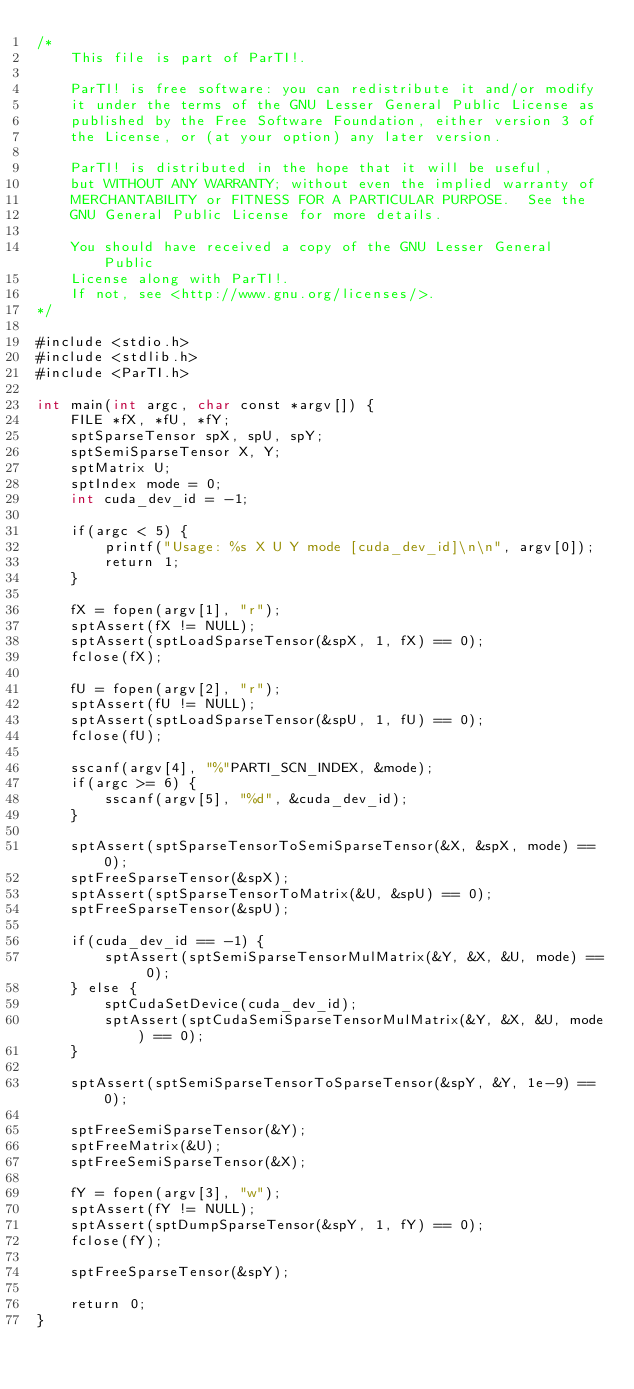<code> <loc_0><loc_0><loc_500><loc_500><_Cuda_>/*
    This file is part of ParTI!.

    ParTI! is free software: you can redistribute it and/or modify
    it under the terms of the GNU Lesser General Public License as
    published by the Free Software Foundation, either version 3 of
    the License, or (at your option) any later version.

    ParTI! is distributed in the hope that it will be useful,
    but WITHOUT ANY WARRANTY; without even the implied warranty of
    MERCHANTABILITY or FITNESS FOR A PARTICULAR PURPOSE.  See the
    GNU General Public License for more details.

    You should have received a copy of the GNU Lesser General Public
    License along with ParTI!.
    If not, see <http://www.gnu.org/licenses/>.
*/

#include <stdio.h>
#include <stdlib.h>
#include <ParTI.h>

int main(int argc, char const *argv[]) {
    FILE *fX, *fU, *fY;
    sptSparseTensor spX, spU, spY;
    sptSemiSparseTensor X, Y;
    sptMatrix U;
    sptIndex mode = 0;
    int cuda_dev_id = -1;

    if(argc < 5) {
        printf("Usage: %s X U Y mode [cuda_dev_id]\n\n", argv[0]);
        return 1;
    }

    fX = fopen(argv[1], "r");
    sptAssert(fX != NULL);
    sptAssert(sptLoadSparseTensor(&spX, 1, fX) == 0);
    fclose(fX);

    fU = fopen(argv[2], "r");
    sptAssert(fU != NULL);
    sptAssert(sptLoadSparseTensor(&spU, 1, fU) == 0);
    fclose(fU);

    sscanf(argv[4], "%"PARTI_SCN_INDEX, &mode);
    if(argc >= 6) {
        sscanf(argv[5], "%d", &cuda_dev_id);
    }

    sptAssert(sptSparseTensorToSemiSparseTensor(&X, &spX, mode) == 0);
    sptFreeSparseTensor(&spX);
    sptAssert(sptSparseTensorToMatrix(&U, &spU) == 0);
    sptFreeSparseTensor(&spU);

    if(cuda_dev_id == -1) {
        sptAssert(sptSemiSparseTensorMulMatrix(&Y, &X, &U, mode) == 0);
    } else {
        sptCudaSetDevice(cuda_dev_id);
        sptAssert(sptCudaSemiSparseTensorMulMatrix(&Y, &X, &U, mode) == 0);
    }

    sptAssert(sptSemiSparseTensorToSparseTensor(&spY, &Y, 1e-9) == 0);

    sptFreeSemiSparseTensor(&Y);
    sptFreeMatrix(&U);
    sptFreeSemiSparseTensor(&X);

    fY = fopen(argv[3], "w");
    sptAssert(fY != NULL);
    sptAssert(sptDumpSparseTensor(&spY, 1, fY) == 0);
    fclose(fY);

    sptFreeSparseTensor(&spY);

    return 0;
}
</code> 